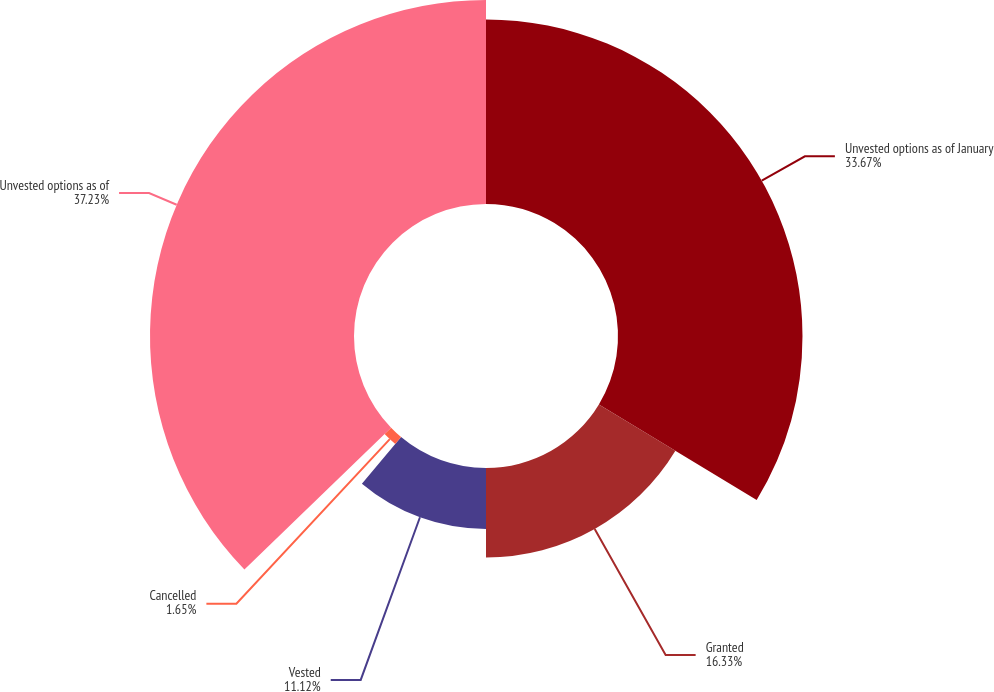Convert chart. <chart><loc_0><loc_0><loc_500><loc_500><pie_chart><fcel>Unvested options as of January<fcel>Granted<fcel>Vested<fcel>Cancelled<fcel>Unvested options as of<nl><fcel>33.67%<fcel>16.33%<fcel>11.12%<fcel>1.65%<fcel>37.23%<nl></chart> 